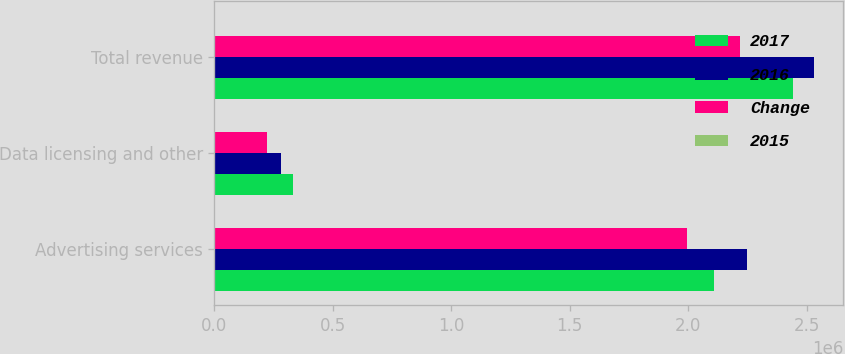Convert chart to OTSL. <chart><loc_0><loc_0><loc_500><loc_500><stacked_bar_chart><ecel><fcel>Advertising services<fcel>Data licensing and other<fcel>Total revenue<nl><fcel>2017<fcel>2.10999e+06<fcel>333312<fcel>2.4433e+06<nl><fcel>2016<fcel>2.24805e+06<fcel>281567<fcel>2.52962e+06<nl><fcel>Change<fcel>1.99404e+06<fcel>223996<fcel>2.21803e+06<nl><fcel>2015<fcel>6<fcel>18<fcel>3<nl></chart> 